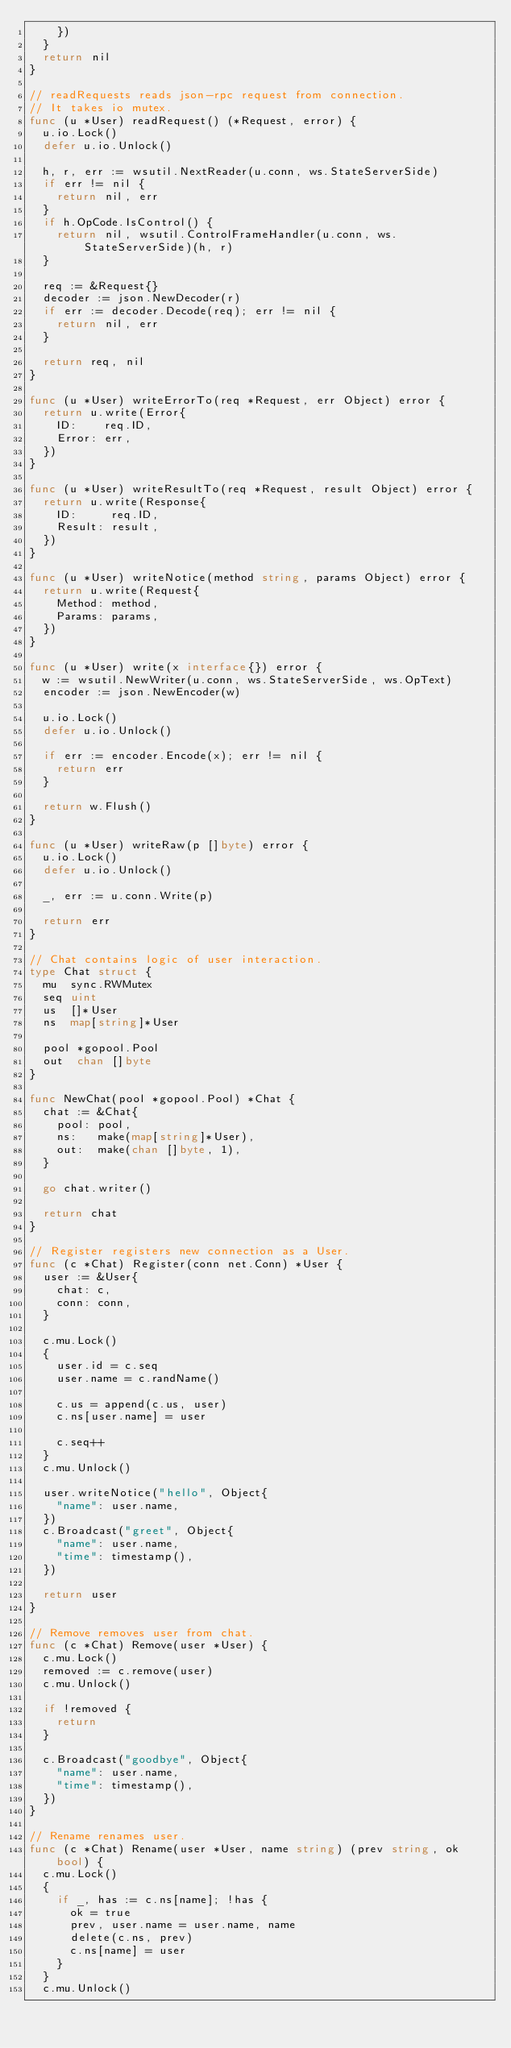Convert code to text. <code><loc_0><loc_0><loc_500><loc_500><_Go_>		})
	}
	return nil
}

// readRequests reads json-rpc request from connection.
// It takes io mutex.
func (u *User) readRequest() (*Request, error) {
	u.io.Lock()
	defer u.io.Unlock()

	h, r, err := wsutil.NextReader(u.conn, ws.StateServerSide)
	if err != nil {
		return nil, err
	}
	if h.OpCode.IsControl() {
		return nil, wsutil.ControlFrameHandler(u.conn, ws.StateServerSide)(h, r)
	}

	req := &Request{}
	decoder := json.NewDecoder(r)
	if err := decoder.Decode(req); err != nil {
		return nil, err
	}

	return req, nil
}

func (u *User) writeErrorTo(req *Request, err Object) error {
	return u.write(Error{
		ID:    req.ID,
		Error: err,
	})
}

func (u *User) writeResultTo(req *Request, result Object) error {
	return u.write(Response{
		ID:     req.ID,
		Result: result,
	})
}

func (u *User) writeNotice(method string, params Object) error {
	return u.write(Request{
		Method: method,
		Params: params,
	})
}

func (u *User) write(x interface{}) error {
	w := wsutil.NewWriter(u.conn, ws.StateServerSide, ws.OpText)
	encoder := json.NewEncoder(w)

	u.io.Lock()
	defer u.io.Unlock()

	if err := encoder.Encode(x); err != nil {
		return err
	}

	return w.Flush()
}

func (u *User) writeRaw(p []byte) error {
	u.io.Lock()
	defer u.io.Unlock()

	_, err := u.conn.Write(p)

	return err
}

// Chat contains logic of user interaction.
type Chat struct {
	mu  sync.RWMutex
	seq uint
	us  []*User
	ns  map[string]*User

	pool *gopool.Pool
	out  chan []byte
}

func NewChat(pool *gopool.Pool) *Chat {
	chat := &Chat{
		pool: pool,
		ns:   make(map[string]*User),
		out:  make(chan []byte, 1),
	}

	go chat.writer()

	return chat
}

// Register registers new connection as a User.
func (c *Chat) Register(conn net.Conn) *User {
	user := &User{
		chat: c,
		conn: conn,
	}

	c.mu.Lock()
	{
		user.id = c.seq
		user.name = c.randName()

		c.us = append(c.us, user)
		c.ns[user.name] = user

		c.seq++
	}
	c.mu.Unlock()

	user.writeNotice("hello", Object{
		"name": user.name,
	})
	c.Broadcast("greet", Object{
		"name": user.name,
		"time": timestamp(),
	})

	return user
}

// Remove removes user from chat.
func (c *Chat) Remove(user *User) {
	c.mu.Lock()
	removed := c.remove(user)
	c.mu.Unlock()

	if !removed {
		return
	}

	c.Broadcast("goodbye", Object{
		"name": user.name,
		"time": timestamp(),
	})
}

// Rename renames user.
func (c *Chat) Rename(user *User, name string) (prev string, ok bool) {
	c.mu.Lock()
	{
		if _, has := c.ns[name]; !has {
			ok = true
			prev, user.name = user.name, name
			delete(c.ns, prev)
			c.ns[name] = user
		}
	}
	c.mu.Unlock()
</code> 